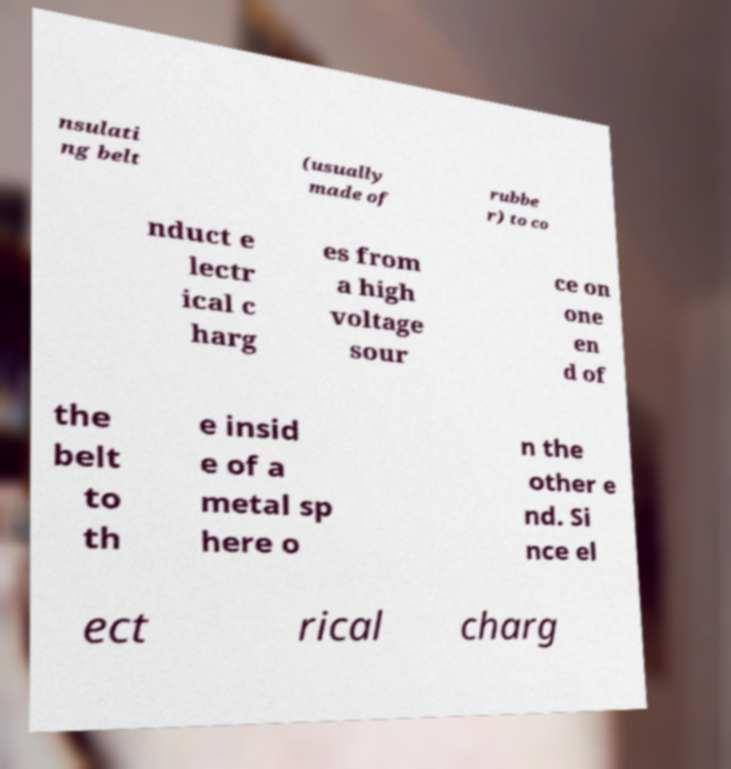Could you extract and type out the text from this image? nsulati ng belt (usually made of rubbe r) to co nduct e lectr ical c harg es from a high voltage sour ce on one en d of the belt to th e insid e of a metal sp here o n the other e nd. Si nce el ect rical charg 